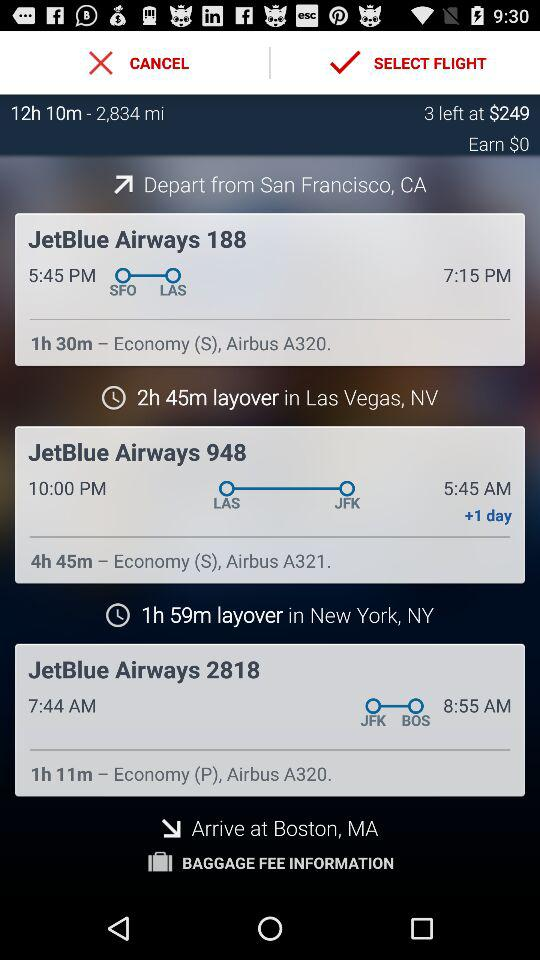How long is the layover in New York?
Answer the question using a single word or phrase. 1h 59m 